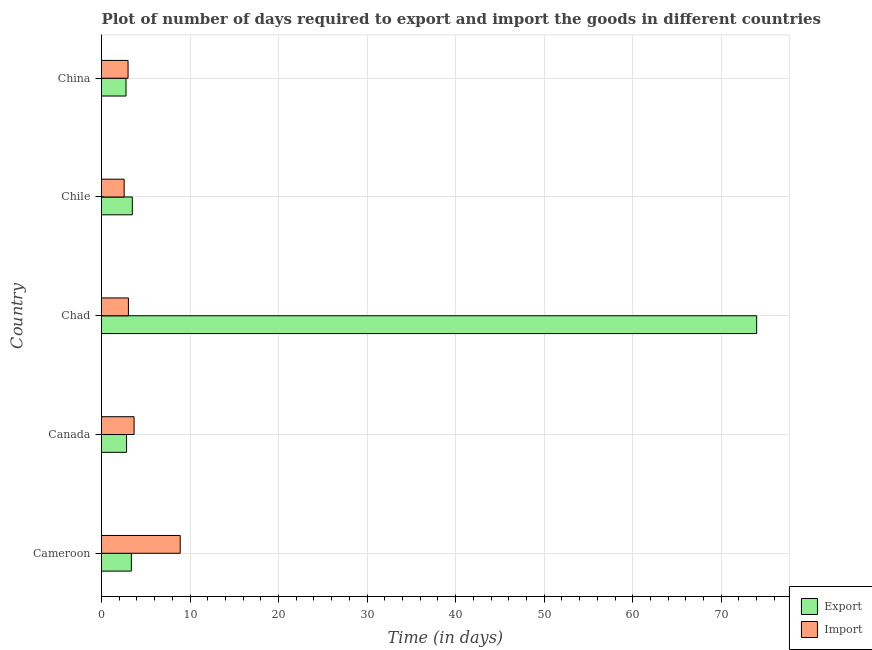How many bars are there on the 3rd tick from the top?
Keep it short and to the point. 2. How many bars are there on the 3rd tick from the bottom?
Your response must be concise. 2. What is the label of the 3rd group of bars from the top?
Offer a terse response. Chad. In how many cases, is the number of bars for a given country not equal to the number of legend labels?
Offer a terse response. 0. What is the time required to export in Canada?
Offer a very short reply. 2.83. Across all countries, what is the minimum time required to import?
Offer a very short reply. 2.56. In which country was the time required to import maximum?
Provide a succinct answer. Cameroon. In which country was the time required to import minimum?
Provide a short and direct response. Chile. What is the total time required to export in the graph?
Provide a succinct answer. 86.45. What is the difference between the time required to import in China and the time required to export in Canada?
Keep it short and to the point. 0.17. What is the average time required to import per country?
Your answer should be compact. 4.23. What is the difference between the time required to import and time required to export in China?
Provide a short and direct response. 0.23. In how many countries, is the time required to export greater than 64 days?
Your response must be concise. 1. What is the ratio of the time required to import in Canada to that in Chad?
Offer a very short reply. 1.21. Is the difference between the time required to export in Cameroon and Canada greater than the difference between the time required to import in Cameroon and Canada?
Your answer should be very brief. No. What is the difference between the highest and the second highest time required to export?
Keep it short and to the point. 70.52. What is the difference between the highest and the lowest time required to export?
Your answer should be very brief. 71.23. In how many countries, is the time required to import greater than the average time required to import taken over all countries?
Your answer should be compact. 1. What does the 2nd bar from the top in Chad represents?
Your response must be concise. Export. What does the 1st bar from the bottom in Canada represents?
Provide a succinct answer. Export. How many bars are there?
Make the answer very short. 10. How many countries are there in the graph?
Ensure brevity in your answer.  5. Are the values on the major ticks of X-axis written in scientific E-notation?
Your answer should be compact. No. Does the graph contain any zero values?
Provide a succinct answer. No. What is the title of the graph?
Offer a very short reply. Plot of number of days required to export and import the goods in different countries. Does "Lowest 20% of population" appear as one of the legend labels in the graph?
Your answer should be compact. No. What is the label or title of the X-axis?
Offer a very short reply. Time (in days). What is the Time (in days) of Export in Cameroon?
Offer a terse response. 3.37. What is the Time (in days) in Import in Cameroon?
Offer a terse response. 8.89. What is the Time (in days) of Export in Canada?
Offer a terse response. 2.83. What is the Time (in days) of Import in Canada?
Provide a short and direct response. 3.68. What is the Time (in days) of Export in Chad?
Provide a succinct answer. 74. What is the Time (in days) of Import in Chad?
Your answer should be compact. 3.04. What is the Time (in days) of Export in Chile?
Provide a succinct answer. 3.48. What is the Time (in days) in Import in Chile?
Offer a very short reply. 2.56. What is the Time (in days) in Export in China?
Your answer should be very brief. 2.77. Across all countries, what is the maximum Time (in days) of Import?
Make the answer very short. 8.89. Across all countries, what is the minimum Time (in days) in Export?
Make the answer very short. 2.77. Across all countries, what is the minimum Time (in days) in Import?
Ensure brevity in your answer.  2.56. What is the total Time (in days) of Export in the graph?
Provide a short and direct response. 86.45. What is the total Time (in days) in Import in the graph?
Provide a short and direct response. 21.17. What is the difference between the Time (in days) of Export in Cameroon and that in Canada?
Your answer should be compact. 0.54. What is the difference between the Time (in days) in Import in Cameroon and that in Canada?
Keep it short and to the point. 5.21. What is the difference between the Time (in days) of Export in Cameroon and that in Chad?
Provide a short and direct response. -70.63. What is the difference between the Time (in days) of Import in Cameroon and that in Chad?
Offer a very short reply. 5.85. What is the difference between the Time (in days) in Export in Cameroon and that in Chile?
Offer a very short reply. -0.11. What is the difference between the Time (in days) in Import in Cameroon and that in Chile?
Your response must be concise. 6.33. What is the difference between the Time (in days) of Import in Cameroon and that in China?
Ensure brevity in your answer.  5.89. What is the difference between the Time (in days) of Export in Canada and that in Chad?
Keep it short and to the point. -71.17. What is the difference between the Time (in days) in Import in Canada and that in Chad?
Keep it short and to the point. 0.64. What is the difference between the Time (in days) in Export in Canada and that in Chile?
Provide a short and direct response. -0.65. What is the difference between the Time (in days) of Import in Canada and that in Chile?
Offer a terse response. 1.12. What is the difference between the Time (in days) in Import in Canada and that in China?
Offer a very short reply. 0.68. What is the difference between the Time (in days) in Export in Chad and that in Chile?
Offer a terse response. 70.52. What is the difference between the Time (in days) in Import in Chad and that in Chile?
Provide a short and direct response. 0.48. What is the difference between the Time (in days) in Export in Chad and that in China?
Give a very brief answer. 71.23. What is the difference between the Time (in days) in Import in Chad and that in China?
Your answer should be compact. 0.04. What is the difference between the Time (in days) of Export in Chile and that in China?
Your answer should be compact. 0.71. What is the difference between the Time (in days) of Import in Chile and that in China?
Give a very brief answer. -0.44. What is the difference between the Time (in days) in Export in Cameroon and the Time (in days) in Import in Canada?
Provide a succinct answer. -0.31. What is the difference between the Time (in days) of Export in Cameroon and the Time (in days) of Import in Chad?
Keep it short and to the point. 0.33. What is the difference between the Time (in days) of Export in Cameroon and the Time (in days) of Import in Chile?
Provide a short and direct response. 0.81. What is the difference between the Time (in days) of Export in Cameroon and the Time (in days) of Import in China?
Offer a terse response. 0.37. What is the difference between the Time (in days) of Export in Canada and the Time (in days) of Import in Chad?
Offer a terse response. -0.21. What is the difference between the Time (in days) in Export in Canada and the Time (in days) in Import in Chile?
Provide a succinct answer. 0.27. What is the difference between the Time (in days) of Export in Canada and the Time (in days) of Import in China?
Offer a very short reply. -0.17. What is the difference between the Time (in days) in Export in Chad and the Time (in days) in Import in Chile?
Your answer should be very brief. 71.44. What is the difference between the Time (in days) in Export in Chad and the Time (in days) in Import in China?
Your response must be concise. 71. What is the difference between the Time (in days) of Export in Chile and the Time (in days) of Import in China?
Make the answer very short. 0.48. What is the average Time (in days) in Export per country?
Make the answer very short. 17.29. What is the average Time (in days) in Import per country?
Give a very brief answer. 4.23. What is the difference between the Time (in days) of Export and Time (in days) of Import in Cameroon?
Offer a terse response. -5.52. What is the difference between the Time (in days) of Export and Time (in days) of Import in Canada?
Ensure brevity in your answer.  -0.85. What is the difference between the Time (in days) of Export and Time (in days) of Import in Chad?
Give a very brief answer. 70.96. What is the difference between the Time (in days) in Export and Time (in days) in Import in China?
Provide a succinct answer. -0.23. What is the ratio of the Time (in days) in Export in Cameroon to that in Canada?
Your answer should be very brief. 1.19. What is the ratio of the Time (in days) of Import in Cameroon to that in Canada?
Offer a very short reply. 2.42. What is the ratio of the Time (in days) in Export in Cameroon to that in Chad?
Offer a very short reply. 0.05. What is the ratio of the Time (in days) of Import in Cameroon to that in Chad?
Offer a terse response. 2.92. What is the ratio of the Time (in days) in Export in Cameroon to that in Chile?
Keep it short and to the point. 0.97. What is the ratio of the Time (in days) of Import in Cameroon to that in Chile?
Offer a terse response. 3.47. What is the ratio of the Time (in days) of Export in Cameroon to that in China?
Make the answer very short. 1.22. What is the ratio of the Time (in days) in Import in Cameroon to that in China?
Give a very brief answer. 2.96. What is the ratio of the Time (in days) in Export in Canada to that in Chad?
Keep it short and to the point. 0.04. What is the ratio of the Time (in days) in Import in Canada to that in Chad?
Offer a terse response. 1.21. What is the ratio of the Time (in days) in Export in Canada to that in Chile?
Give a very brief answer. 0.81. What is the ratio of the Time (in days) in Import in Canada to that in Chile?
Your answer should be compact. 1.44. What is the ratio of the Time (in days) of Export in Canada to that in China?
Offer a terse response. 1.02. What is the ratio of the Time (in days) of Import in Canada to that in China?
Keep it short and to the point. 1.23. What is the ratio of the Time (in days) of Export in Chad to that in Chile?
Make the answer very short. 21.26. What is the ratio of the Time (in days) of Import in Chad to that in Chile?
Give a very brief answer. 1.19. What is the ratio of the Time (in days) in Export in Chad to that in China?
Provide a succinct answer. 26.71. What is the ratio of the Time (in days) in Import in Chad to that in China?
Provide a short and direct response. 1.01. What is the ratio of the Time (in days) of Export in Chile to that in China?
Ensure brevity in your answer.  1.26. What is the ratio of the Time (in days) in Import in Chile to that in China?
Your answer should be very brief. 0.85. What is the difference between the highest and the second highest Time (in days) in Export?
Provide a succinct answer. 70.52. What is the difference between the highest and the second highest Time (in days) of Import?
Give a very brief answer. 5.21. What is the difference between the highest and the lowest Time (in days) of Export?
Keep it short and to the point. 71.23. What is the difference between the highest and the lowest Time (in days) of Import?
Give a very brief answer. 6.33. 